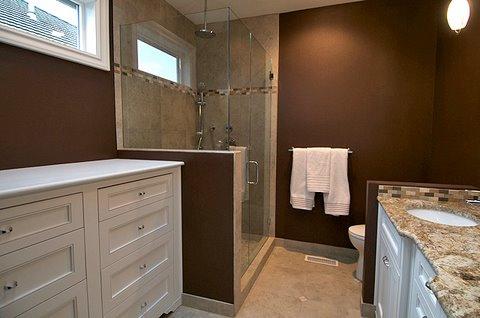Are these walls too dark?
Quick response, please. Yes. How many towels are hanging?
Give a very brief answer. 3. How many towels are in this photo?
Keep it brief. 3. 